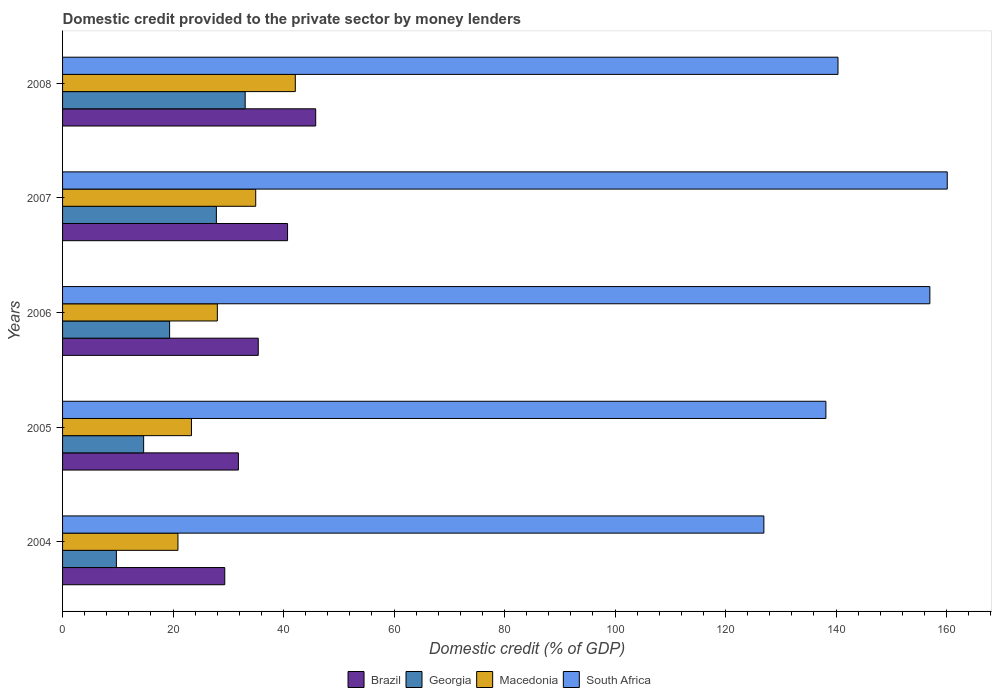How many different coloured bars are there?
Provide a succinct answer. 4. Are the number of bars on each tick of the Y-axis equal?
Your answer should be very brief. Yes. What is the domestic credit provided to the private sector by money lenders in Macedonia in 2004?
Provide a succinct answer. 20.88. Across all years, what is the maximum domestic credit provided to the private sector by money lenders in Macedonia?
Ensure brevity in your answer.  42.13. Across all years, what is the minimum domestic credit provided to the private sector by money lenders in South Africa?
Keep it short and to the point. 126.93. In which year was the domestic credit provided to the private sector by money lenders in Macedonia minimum?
Ensure brevity in your answer.  2004. What is the total domestic credit provided to the private sector by money lenders in Brazil in the graph?
Your answer should be compact. 183.14. What is the difference between the domestic credit provided to the private sector by money lenders in Georgia in 2004 and that in 2007?
Ensure brevity in your answer.  -18.1. What is the difference between the domestic credit provided to the private sector by money lenders in Georgia in 2004 and the domestic credit provided to the private sector by money lenders in Macedonia in 2007?
Your response must be concise. -25.22. What is the average domestic credit provided to the private sector by money lenders in Brazil per year?
Give a very brief answer. 36.63. In the year 2005, what is the difference between the domestic credit provided to the private sector by money lenders in Macedonia and domestic credit provided to the private sector by money lenders in South Africa?
Ensure brevity in your answer.  -114.83. What is the ratio of the domestic credit provided to the private sector by money lenders in South Africa in 2004 to that in 2006?
Provide a succinct answer. 0.81. Is the domestic credit provided to the private sector by money lenders in Georgia in 2004 less than that in 2005?
Provide a succinct answer. Yes. What is the difference between the highest and the second highest domestic credit provided to the private sector by money lenders in Macedonia?
Offer a terse response. 7.17. What is the difference between the highest and the lowest domestic credit provided to the private sector by money lenders in Brazil?
Your response must be concise. 16.46. Is the sum of the domestic credit provided to the private sector by money lenders in Georgia in 2004 and 2007 greater than the maximum domestic credit provided to the private sector by money lenders in Brazil across all years?
Ensure brevity in your answer.  No. Is it the case that in every year, the sum of the domestic credit provided to the private sector by money lenders in Macedonia and domestic credit provided to the private sector by money lenders in Brazil is greater than the sum of domestic credit provided to the private sector by money lenders in Georgia and domestic credit provided to the private sector by money lenders in South Africa?
Your answer should be compact. No. What does the 1st bar from the top in 2008 represents?
Give a very brief answer. South Africa. What does the 1st bar from the bottom in 2007 represents?
Provide a short and direct response. Brazil. Is it the case that in every year, the sum of the domestic credit provided to the private sector by money lenders in Brazil and domestic credit provided to the private sector by money lenders in South Africa is greater than the domestic credit provided to the private sector by money lenders in Georgia?
Ensure brevity in your answer.  Yes. How many bars are there?
Offer a terse response. 20. Are all the bars in the graph horizontal?
Provide a short and direct response. Yes. How many years are there in the graph?
Keep it short and to the point. 5. What is the difference between two consecutive major ticks on the X-axis?
Offer a very short reply. 20. Does the graph contain any zero values?
Ensure brevity in your answer.  No. How many legend labels are there?
Give a very brief answer. 4. How are the legend labels stacked?
Make the answer very short. Horizontal. What is the title of the graph?
Make the answer very short. Domestic credit provided to the private sector by money lenders. Does "Croatia" appear as one of the legend labels in the graph?
Offer a terse response. No. What is the label or title of the X-axis?
Offer a very short reply. Domestic credit (% of GDP). What is the Domestic credit (% of GDP) of Brazil in 2004?
Your answer should be very brief. 29.36. What is the Domestic credit (% of GDP) of Georgia in 2004?
Your response must be concise. 9.74. What is the Domestic credit (% of GDP) of Macedonia in 2004?
Ensure brevity in your answer.  20.88. What is the Domestic credit (% of GDP) in South Africa in 2004?
Keep it short and to the point. 126.93. What is the Domestic credit (% of GDP) of Brazil in 2005?
Keep it short and to the point. 31.82. What is the Domestic credit (% of GDP) in Georgia in 2005?
Give a very brief answer. 14.67. What is the Domestic credit (% of GDP) in Macedonia in 2005?
Your answer should be compact. 23.33. What is the Domestic credit (% of GDP) in South Africa in 2005?
Keep it short and to the point. 138.16. What is the Domestic credit (% of GDP) of Brazil in 2006?
Provide a short and direct response. 35.42. What is the Domestic credit (% of GDP) of Georgia in 2006?
Provide a succinct answer. 19.37. What is the Domestic credit (% of GDP) of Macedonia in 2006?
Ensure brevity in your answer.  28.01. What is the Domestic credit (% of GDP) of South Africa in 2006?
Your response must be concise. 156.98. What is the Domestic credit (% of GDP) in Brazil in 2007?
Make the answer very short. 40.72. What is the Domestic credit (% of GDP) of Georgia in 2007?
Give a very brief answer. 27.84. What is the Domestic credit (% of GDP) of Macedonia in 2007?
Your answer should be compact. 34.96. What is the Domestic credit (% of GDP) in South Africa in 2007?
Offer a very short reply. 160.12. What is the Domestic credit (% of GDP) of Brazil in 2008?
Give a very brief answer. 45.82. What is the Domestic credit (% of GDP) of Georgia in 2008?
Your answer should be compact. 33.05. What is the Domestic credit (% of GDP) of Macedonia in 2008?
Give a very brief answer. 42.13. What is the Domestic credit (% of GDP) of South Africa in 2008?
Offer a very short reply. 140.35. Across all years, what is the maximum Domestic credit (% of GDP) in Brazil?
Your answer should be very brief. 45.82. Across all years, what is the maximum Domestic credit (% of GDP) in Georgia?
Offer a terse response. 33.05. Across all years, what is the maximum Domestic credit (% of GDP) of Macedonia?
Make the answer very short. 42.13. Across all years, what is the maximum Domestic credit (% of GDP) of South Africa?
Make the answer very short. 160.12. Across all years, what is the minimum Domestic credit (% of GDP) in Brazil?
Provide a succinct answer. 29.36. Across all years, what is the minimum Domestic credit (% of GDP) of Georgia?
Provide a succinct answer. 9.74. Across all years, what is the minimum Domestic credit (% of GDP) in Macedonia?
Offer a very short reply. 20.88. Across all years, what is the minimum Domestic credit (% of GDP) of South Africa?
Provide a short and direct response. 126.93. What is the total Domestic credit (% of GDP) of Brazil in the graph?
Ensure brevity in your answer.  183.14. What is the total Domestic credit (% of GDP) in Georgia in the graph?
Your response must be concise. 104.68. What is the total Domestic credit (% of GDP) in Macedonia in the graph?
Your answer should be very brief. 149.32. What is the total Domestic credit (% of GDP) of South Africa in the graph?
Offer a terse response. 722.54. What is the difference between the Domestic credit (% of GDP) in Brazil in 2004 and that in 2005?
Keep it short and to the point. -2.46. What is the difference between the Domestic credit (% of GDP) in Georgia in 2004 and that in 2005?
Keep it short and to the point. -4.93. What is the difference between the Domestic credit (% of GDP) in Macedonia in 2004 and that in 2005?
Give a very brief answer. -2.45. What is the difference between the Domestic credit (% of GDP) of South Africa in 2004 and that in 2005?
Ensure brevity in your answer.  -11.23. What is the difference between the Domestic credit (% of GDP) of Brazil in 2004 and that in 2006?
Your answer should be very brief. -6.06. What is the difference between the Domestic credit (% of GDP) in Georgia in 2004 and that in 2006?
Make the answer very short. -9.63. What is the difference between the Domestic credit (% of GDP) in Macedonia in 2004 and that in 2006?
Offer a terse response. -7.13. What is the difference between the Domestic credit (% of GDP) of South Africa in 2004 and that in 2006?
Offer a very short reply. -30.04. What is the difference between the Domestic credit (% of GDP) of Brazil in 2004 and that in 2007?
Offer a terse response. -11.37. What is the difference between the Domestic credit (% of GDP) in Georgia in 2004 and that in 2007?
Offer a terse response. -18.1. What is the difference between the Domestic credit (% of GDP) of Macedonia in 2004 and that in 2007?
Ensure brevity in your answer.  -14.08. What is the difference between the Domestic credit (% of GDP) of South Africa in 2004 and that in 2007?
Ensure brevity in your answer.  -33.19. What is the difference between the Domestic credit (% of GDP) in Brazil in 2004 and that in 2008?
Provide a succinct answer. -16.46. What is the difference between the Domestic credit (% of GDP) of Georgia in 2004 and that in 2008?
Your response must be concise. -23.31. What is the difference between the Domestic credit (% of GDP) of Macedonia in 2004 and that in 2008?
Your response must be concise. -21.24. What is the difference between the Domestic credit (% of GDP) of South Africa in 2004 and that in 2008?
Give a very brief answer. -13.42. What is the difference between the Domestic credit (% of GDP) of Brazil in 2005 and that in 2006?
Offer a terse response. -3.6. What is the difference between the Domestic credit (% of GDP) in Georgia in 2005 and that in 2006?
Your answer should be very brief. -4.7. What is the difference between the Domestic credit (% of GDP) in Macedonia in 2005 and that in 2006?
Make the answer very short. -4.68. What is the difference between the Domestic credit (% of GDP) in South Africa in 2005 and that in 2006?
Offer a terse response. -18.82. What is the difference between the Domestic credit (% of GDP) in Brazil in 2005 and that in 2007?
Give a very brief answer. -8.9. What is the difference between the Domestic credit (% of GDP) in Georgia in 2005 and that in 2007?
Your answer should be very brief. -13.16. What is the difference between the Domestic credit (% of GDP) of Macedonia in 2005 and that in 2007?
Offer a terse response. -11.63. What is the difference between the Domestic credit (% of GDP) of South Africa in 2005 and that in 2007?
Your answer should be compact. -21.97. What is the difference between the Domestic credit (% of GDP) of Brazil in 2005 and that in 2008?
Provide a succinct answer. -13.99. What is the difference between the Domestic credit (% of GDP) of Georgia in 2005 and that in 2008?
Keep it short and to the point. -18.38. What is the difference between the Domestic credit (% of GDP) of Macedonia in 2005 and that in 2008?
Offer a terse response. -18.8. What is the difference between the Domestic credit (% of GDP) of South Africa in 2005 and that in 2008?
Offer a very short reply. -2.19. What is the difference between the Domestic credit (% of GDP) in Brazil in 2006 and that in 2007?
Make the answer very short. -5.3. What is the difference between the Domestic credit (% of GDP) of Georgia in 2006 and that in 2007?
Give a very brief answer. -8.46. What is the difference between the Domestic credit (% of GDP) of Macedonia in 2006 and that in 2007?
Ensure brevity in your answer.  -6.95. What is the difference between the Domestic credit (% of GDP) of South Africa in 2006 and that in 2007?
Provide a succinct answer. -3.15. What is the difference between the Domestic credit (% of GDP) of Brazil in 2006 and that in 2008?
Your answer should be very brief. -10.4. What is the difference between the Domestic credit (% of GDP) of Georgia in 2006 and that in 2008?
Provide a short and direct response. -13.68. What is the difference between the Domestic credit (% of GDP) of Macedonia in 2006 and that in 2008?
Make the answer very short. -14.11. What is the difference between the Domestic credit (% of GDP) of South Africa in 2006 and that in 2008?
Offer a very short reply. 16.63. What is the difference between the Domestic credit (% of GDP) of Brazil in 2007 and that in 2008?
Give a very brief answer. -5.09. What is the difference between the Domestic credit (% of GDP) in Georgia in 2007 and that in 2008?
Keep it short and to the point. -5.21. What is the difference between the Domestic credit (% of GDP) of Macedonia in 2007 and that in 2008?
Your answer should be compact. -7.17. What is the difference between the Domestic credit (% of GDP) in South Africa in 2007 and that in 2008?
Your answer should be very brief. 19.77. What is the difference between the Domestic credit (% of GDP) of Brazil in 2004 and the Domestic credit (% of GDP) of Georgia in 2005?
Provide a succinct answer. 14.68. What is the difference between the Domestic credit (% of GDP) in Brazil in 2004 and the Domestic credit (% of GDP) in Macedonia in 2005?
Ensure brevity in your answer.  6.03. What is the difference between the Domestic credit (% of GDP) of Brazil in 2004 and the Domestic credit (% of GDP) of South Africa in 2005?
Ensure brevity in your answer.  -108.8. What is the difference between the Domestic credit (% of GDP) in Georgia in 2004 and the Domestic credit (% of GDP) in Macedonia in 2005?
Offer a very short reply. -13.59. What is the difference between the Domestic credit (% of GDP) in Georgia in 2004 and the Domestic credit (% of GDP) in South Africa in 2005?
Your response must be concise. -128.42. What is the difference between the Domestic credit (% of GDP) in Macedonia in 2004 and the Domestic credit (% of GDP) in South Africa in 2005?
Your answer should be very brief. -117.28. What is the difference between the Domestic credit (% of GDP) of Brazil in 2004 and the Domestic credit (% of GDP) of Georgia in 2006?
Your answer should be very brief. 9.98. What is the difference between the Domestic credit (% of GDP) in Brazil in 2004 and the Domestic credit (% of GDP) in Macedonia in 2006?
Provide a succinct answer. 1.34. What is the difference between the Domestic credit (% of GDP) of Brazil in 2004 and the Domestic credit (% of GDP) of South Africa in 2006?
Make the answer very short. -127.62. What is the difference between the Domestic credit (% of GDP) in Georgia in 2004 and the Domestic credit (% of GDP) in Macedonia in 2006?
Make the answer very short. -18.27. What is the difference between the Domestic credit (% of GDP) in Georgia in 2004 and the Domestic credit (% of GDP) in South Africa in 2006?
Your response must be concise. -147.23. What is the difference between the Domestic credit (% of GDP) of Macedonia in 2004 and the Domestic credit (% of GDP) of South Africa in 2006?
Your answer should be very brief. -136.09. What is the difference between the Domestic credit (% of GDP) of Brazil in 2004 and the Domestic credit (% of GDP) of Georgia in 2007?
Provide a succinct answer. 1.52. What is the difference between the Domestic credit (% of GDP) in Brazil in 2004 and the Domestic credit (% of GDP) in Macedonia in 2007?
Your answer should be compact. -5.6. What is the difference between the Domestic credit (% of GDP) of Brazil in 2004 and the Domestic credit (% of GDP) of South Africa in 2007?
Offer a very short reply. -130.77. What is the difference between the Domestic credit (% of GDP) in Georgia in 2004 and the Domestic credit (% of GDP) in Macedonia in 2007?
Keep it short and to the point. -25.22. What is the difference between the Domestic credit (% of GDP) in Georgia in 2004 and the Domestic credit (% of GDP) in South Africa in 2007?
Provide a short and direct response. -150.38. What is the difference between the Domestic credit (% of GDP) of Macedonia in 2004 and the Domestic credit (% of GDP) of South Africa in 2007?
Offer a terse response. -139.24. What is the difference between the Domestic credit (% of GDP) in Brazil in 2004 and the Domestic credit (% of GDP) in Georgia in 2008?
Keep it short and to the point. -3.69. What is the difference between the Domestic credit (% of GDP) of Brazil in 2004 and the Domestic credit (% of GDP) of Macedonia in 2008?
Provide a short and direct response. -12.77. What is the difference between the Domestic credit (% of GDP) of Brazil in 2004 and the Domestic credit (% of GDP) of South Africa in 2008?
Your answer should be very brief. -110.99. What is the difference between the Domestic credit (% of GDP) in Georgia in 2004 and the Domestic credit (% of GDP) in Macedonia in 2008?
Offer a very short reply. -32.39. What is the difference between the Domestic credit (% of GDP) of Georgia in 2004 and the Domestic credit (% of GDP) of South Africa in 2008?
Keep it short and to the point. -130.61. What is the difference between the Domestic credit (% of GDP) of Macedonia in 2004 and the Domestic credit (% of GDP) of South Africa in 2008?
Make the answer very short. -119.47. What is the difference between the Domestic credit (% of GDP) in Brazil in 2005 and the Domestic credit (% of GDP) in Georgia in 2006?
Offer a very short reply. 12.45. What is the difference between the Domestic credit (% of GDP) of Brazil in 2005 and the Domestic credit (% of GDP) of Macedonia in 2006?
Give a very brief answer. 3.81. What is the difference between the Domestic credit (% of GDP) of Brazil in 2005 and the Domestic credit (% of GDP) of South Africa in 2006?
Offer a terse response. -125.15. What is the difference between the Domestic credit (% of GDP) in Georgia in 2005 and the Domestic credit (% of GDP) in Macedonia in 2006?
Your response must be concise. -13.34. What is the difference between the Domestic credit (% of GDP) in Georgia in 2005 and the Domestic credit (% of GDP) in South Africa in 2006?
Offer a terse response. -142.3. What is the difference between the Domestic credit (% of GDP) of Macedonia in 2005 and the Domestic credit (% of GDP) of South Africa in 2006?
Provide a succinct answer. -133.64. What is the difference between the Domestic credit (% of GDP) in Brazil in 2005 and the Domestic credit (% of GDP) in Georgia in 2007?
Provide a short and direct response. 3.99. What is the difference between the Domestic credit (% of GDP) of Brazil in 2005 and the Domestic credit (% of GDP) of Macedonia in 2007?
Give a very brief answer. -3.14. What is the difference between the Domestic credit (% of GDP) of Brazil in 2005 and the Domestic credit (% of GDP) of South Africa in 2007?
Your response must be concise. -128.3. What is the difference between the Domestic credit (% of GDP) in Georgia in 2005 and the Domestic credit (% of GDP) in Macedonia in 2007?
Offer a very short reply. -20.29. What is the difference between the Domestic credit (% of GDP) of Georgia in 2005 and the Domestic credit (% of GDP) of South Africa in 2007?
Your answer should be compact. -145.45. What is the difference between the Domestic credit (% of GDP) in Macedonia in 2005 and the Domestic credit (% of GDP) in South Africa in 2007?
Make the answer very short. -136.79. What is the difference between the Domestic credit (% of GDP) of Brazil in 2005 and the Domestic credit (% of GDP) of Georgia in 2008?
Give a very brief answer. -1.23. What is the difference between the Domestic credit (% of GDP) of Brazil in 2005 and the Domestic credit (% of GDP) of Macedonia in 2008?
Provide a short and direct response. -10.3. What is the difference between the Domestic credit (% of GDP) in Brazil in 2005 and the Domestic credit (% of GDP) in South Africa in 2008?
Your response must be concise. -108.53. What is the difference between the Domestic credit (% of GDP) in Georgia in 2005 and the Domestic credit (% of GDP) in Macedonia in 2008?
Provide a short and direct response. -27.45. What is the difference between the Domestic credit (% of GDP) in Georgia in 2005 and the Domestic credit (% of GDP) in South Africa in 2008?
Your response must be concise. -125.68. What is the difference between the Domestic credit (% of GDP) of Macedonia in 2005 and the Domestic credit (% of GDP) of South Africa in 2008?
Provide a short and direct response. -117.02. What is the difference between the Domestic credit (% of GDP) in Brazil in 2006 and the Domestic credit (% of GDP) in Georgia in 2007?
Provide a succinct answer. 7.58. What is the difference between the Domestic credit (% of GDP) in Brazil in 2006 and the Domestic credit (% of GDP) in Macedonia in 2007?
Your answer should be very brief. 0.46. What is the difference between the Domestic credit (% of GDP) in Brazil in 2006 and the Domestic credit (% of GDP) in South Africa in 2007?
Offer a very short reply. -124.7. What is the difference between the Domestic credit (% of GDP) of Georgia in 2006 and the Domestic credit (% of GDP) of Macedonia in 2007?
Give a very brief answer. -15.59. What is the difference between the Domestic credit (% of GDP) in Georgia in 2006 and the Domestic credit (% of GDP) in South Africa in 2007?
Offer a terse response. -140.75. What is the difference between the Domestic credit (% of GDP) in Macedonia in 2006 and the Domestic credit (% of GDP) in South Africa in 2007?
Ensure brevity in your answer.  -132.11. What is the difference between the Domestic credit (% of GDP) in Brazil in 2006 and the Domestic credit (% of GDP) in Georgia in 2008?
Give a very brief answer. 2.37. What is the difference between the Domestic credit (% of GDP) of Brazil in 2006 and the Domestic credit (% of GDP) of Macedonia in 2008?
Offer a very short reply. -6.71. What is the difference between the Domestic credit (% of GDP) in Brazil in 2006 and the Domestic credit (% of GDP) in South Africa in 2008?
Ensure brevity in your answer.  -104.93. What is the difference between the Domestic credit (% of GDP) of Georgia in 2006 and the Domestic credit (% of GDP) of Macedonia in 2008?
Offer a very short reply. -22.75. What is the difference between the Domestic credit (% of GDP) of Georgia in 2006 and the Domestic credit (% of GDP) of South Africa in 2008?
Your answer should be compact. -120.98. What is the difference between the Domestic credit (% of GDP) in Macedonia in 2006 and the Domestic credit (% of GDP) in South Africa in 2008?
Ensure brevity in your answer.  -112.34. What is the difference between the Domestic credit (% of GDP) of Brazil in 2007 and the Domestic credit (% of GDP) of Georgia in 2008?
Provide a succinct answer. 7.67. What is the difference between the Domestic credit (% of GDP) in Brazil in 2007 and the Domestic credit (% of GDP) in Macedonia in 2008?
Give a very brief answer. -1.4. What is the difference between the Domestic credit (% of GDP) of Brazil in 2007 and the Domestic credit (% of GDP) of South Africa in 2008?
Offer a very short reply. -99.63. What is the difference between the Domestic credit (% of GDP) of Georgia in 2007 and the Domestic credit (% of GDP) of Macedonia in 2008?
Offer a terse response. -14.29. What is the difference between the Domestic credit (% of GDP) in Georgia in 2007 and the Domestic credit (% of GDP) in South Africa in 2008?
Make the answer very short. -112.51. What is the difference between the Domestic credit (% of GDP) of Macedonia in 2007 and the Domestic credit (% of GDP) of South Africa in 2008?
Your answer should be compact. -105.39. What is the average Domestic credit (% of GDP) in Brazil per year?
Provide a succinct answer. 36.63. What is the average Domestic credit (% of GDP) in Georgia per year?
Your answer should be very brief. 20.94. What is the average Domestic credit (% of GDP) of Macedonia per year?
Keep it short and to the point. 29.86. What is the average Domestic credit (% of GDP) in South Africa per year?
Ensure brevity in your answer.  144.51. In the year 2004, what is the difference between the Domestic credit (% of GDP) of Brazil and Domestic credit (% of GDP) of Georgia?
Ensure brevity in your answer.  19.62. In the year 2004, what is the difference between the Domestic credit (% of GDP) of Brazil and Domestic credit (% of GDP) of Macedonia?
Provide a succinct answer. 8.47. In the year 2004, what is the difference between the Domestic credit (% of GDP) in Brazil and Domestic credit (% of GDP) in South Africa?
Offer a terse response. -97.57. In the year 2004, what is the difference between the Domestic credit (% of GDP) in Georgia and Domestic credit (% of GDP) in Macedonia?
Your answer should be compact. -11.14. In the year 2004, what is the difference between the Domestic credit (% of GDP) of Georgia and Domestic credit (% of GDP) of South Africa?
Provide a short and direct response. -117.19. In the year 2004, what is the difference between the Domestic credit (% of GDP) in Macedonia and Domestic credit (% of GDP) in South Africa?
Your answer should be compact. -106.05. In the year 2005, what is the difference between the Domestic credit (% of GDP) in Brazil and Domestic credit (% of GDP) in Georgia?
Offer a very short reply. 17.15. In the year 2005, what is the difference between the Domestic credit (% of GDP) in Brazil and Domestic credit (% of GDP) in Macedonia?
Your response must be concise. 8.49. In the year 2005, what is the difference between the Domestic credit (% of GDP) of Brazil and Domestic credit (% of GDP) of South Africa?
Make the answer very short. -106.34. In the year 2005, what is the difference between the Domestic credit (% of GDP) of Georgia and Domestic credit (% of GDP) of Macedonia?
Make the answer very short. -8.66. In the year 2005, what is the difference between the Domestic credit (% of GDP) in Georgia and Domestic credit (% of GDP) in South Africa?
Offer a terse response. -123.49. In the year 2005, what is the difference between the Domestic credit (% of GDP) in Macedonia and Domestic credit (% of GDP) in South Africa?
Offer a terse response. -114.83. In the year 2006, what is the difference between the Domestic credit (% of GDP) of Brazil and Domestic credit (% of GDP) of Georgia?
Provide a succinct answer. 16.05. In the year 2006, what is the difference between the Domestic credit (% of GDP) of Brazil and Domestic credit (% of GDP) of Macedonia?
Make the answer very short. 7.41. In the year 2006, what is the difference between the Domestic credit (% of GDP) of Brazil and Domestic credit (% of GDP) of South Africa?
Provide a succinct answer. -121.56. In the year 2006, what is the difference between the Domestic credit (% of GDP) in Georgia and Domestic credit (% of GDP) in Macedonia?
Offer a very short reply. -8.64. In the year 2006, what is the difference between the Domestic credit (% of GDP) of Georgia and Domestic credit (% of GDP) of South Africa?
Keep it short and to the point. -137.6. In the year 2006, what is the difference between the Domestic credit (% of GDP) of Macedonia and Domestic credit (% of GDP) of South Africa?
Give a very brief answer. -128.96. In the year 2007, what is the difference between the Domestic credit (% of GDP) in Brazil and Domestic credit (% of GDP) in Georgia?
Give a very brief answer. 12.89. In the year 2007, what is the difference between the Domestic credit (% of GDP) of Brazil and Domestic credit (% of GDP) of Macedonia?
Your response must be concise. 5.76. In the year 2007, what is the difference between the Domestic credit (% of GDP) in Brazil and Domestic credit (% of GDP) in South Africa?
Provide a succinct answer. -119.4. In the year 2007, what is the difference between the Domestic credit (% of GDP) of Georgia and Domestic credit (% of GDP) of Macedonia?
Your answer should be very brief. -7.12. In the year 2007, what is the difference between the Domestic credit (% of GDP) in Georgia and Domestic credit (% of GDP) in South Africa?
Ensure brevity in your answer.  -132.29. In the year 2007, what is the difference between the Domestic credit (% of GDP) of Macedonia and Domestic credit (% of GDP) of South Africa?
Make the answer very short. -125.16. In the year 2008, what is the difference between the Domestic credit (% of GDP) in Brazil and Domestic credit (% of GDP) in Georgia?
Provide a short and direct response. 12.77. In the year 2008, what is the difference between the Domestic credit (% of GDP) in Brazil and Domestic credit (% of GDP) in Macedonia?
Offer a very short reply. 3.69. In the year 2008, what is the difference between the Domestic credit (% of GDP) of Brazil and Domestic credit (% of GDP) of South Africa?
Your answer should be compact. -94.53. In the year 2008, what is the difference between the Domestic credit (% of GDP) of Georgia and Domestic credit (% of GDP) of Macedonia?
Your answer should be very brief. -9.08. In the year 2008, what is the difference between the Domestic credit (% of GDP) of Georgia and Domestic credit (% of GDP) of South Africa?
Your answer should be very brief. -107.3. In the year 2008, what is the difference between the Domestic credit (% of GDP) in Macedonia and Domestic credit (% of GDP) in South Africa?
Provide a short and direct response. -98.22. What is the ratio of the Domestic credit (% of GDP) of Brazil in 2004 to that in 2005?
Ensure brevity in your answer.  0.92. What is the ratio of the Domestic credit (% of GDP) of Georgia in 2004 to that in 2005?
Provide a succinct answer. 0.66. What is the ratio of the Domestic credit (% of GDP) in Macedonia in 2004 to that in 2005?
Provide a short and direct response. 0.9. What is the ratio of the Domestic credit (% of GDP) of South Africa in 2004 to that in 2005?
Your response must be concise. 0.92. What is the ratio of the Domestic credit (% of GDP) in Brazil in 2004 to that in 2006?
Make the answer very short. 0.83. What is the ratio of the Domestic credit (% of GDP) of Georgia in 2004 to that in 2006?
Offer a very short reply. 0.5. What is the ratio of the Domestic credit (% of GDP) in Macedonia in 2004 to that in 2006?
Give a very brief answer. 0.75. What is the ratio of the Domestic credit (% of GDP) in South Africa in 2004 to that in 2006?
Make the answer very short. 0.81. What is the ratio of the Domestic credit (% of GDP) in Brazil in 2004 to that in 2007?
Provide a short and direct response. 0.72. What is the ratio of the Domestic credit (% of GDP) of Georgia in 2004 to that in 2007?
Offer a terse response. 0.35. What is the ratio of the Domestic credit (% of GDP) of Macedonia in 2004 to that in 2007?
Keep it short and to the point. 0.6. What is the ratio of the Domestic credit (% of GDP) of South Africa in 2004 to that in 2007?
Your response must be concise. 0.79. What is the ratio of the Domestic credit (% of GDP) of Brazil in 2004 to that in 2008?
Your answer should be very brief. 0.64. What is the ratio of the Domestic credit (% of GDP) of Georgia in 2004 to that in 2008?
Your answer should be compact. 0.29. What is the ratio of the Domestic credit (% of GDP) in Macedonia in 2004 to that in 2008?
Your response must be concise. 0.5. What is the ratio of the Domestic credit (% of GDP) in South Africa in 2004 to that in 2008?
Give a very brief answer. 0.9. What is the ratio of the Domestic credit (% of GDP) in Brazil in 2005 to that in 2006?
Ensure brevity in your answer.  0.9. What is the ratio of the Domestic credit (% of GDP) in Georgia in 2005 to that in 2006?
Make the answer very short. 0.76. What is the ratio of the Domestic credit (% of GDP) in Macedonia in 2005 to that in 2006?
Your answer should be compact. 0.83. What is the ratio of the Domestic credit (% of GDP) in South Africa in 2005 to that in 2006?
Ensure brevity in your answer.  0.88. What is the ratio of the Domestic credit (% of GDP) in Brazil in 2005 to that in 2007?
Offer a terse response. 0.78. What is the ratio of the Domestic credit (% of GDP) in Georgia in 2005 to that in 2007?
Provide a short and direct response. 0.53. What is the ratio of the Domestic credit (% of GDP) of Macedonia in 2005 to that in 2007?
Your answer should be very brief. 0.67. What is the ratio of the Domestic credit (% of GDP) of South Africa in 2005 to that in 2007?
Your answer should be compact. 0.86. What is the ratio of the Domestic credit (% of GDP) in Brazil in 2005 to that in 2008?
Make the answer very short. 0.69. What is the ratio of the Domestic credit (% of GDP) of Georgia in 2005 to that in 2008?
Make the answer very short. 0.44. What is the ratio of the Domestic credit (% of GDP) in Macedonia in 2005 to that in 2008?
Ensure brevity in your answer.  0.55. What is the ratio of the Domestic credit (% of GDP) of South Africa in 2005 to that in 2008?
Offer a terse response. 0.98. What is the ratio of the Domestic credit (% of GDP) in Brazil in 2006 to that in 2007?
Offer a very short reply. 0.87. What is the ratio of the Domestic credit (% of GDP) in Georgia in 2006 to that in 2007?
Ensure brevity in your answer.  0.7. What is the ratio of the Domestic credit (% of GDP) of Macedonia in 2006 to that in 2007?
Offer a terse response. 0.8. What is the ratio of the Domestic credit (% of GDP) of South Africa in 2006 to that in 2007?
Ensure brevity in your answer.  0.98. What is the ratio of the Domestic credit (% of GDP) in Brazil in 2006 to that in 2008?
Ensure brevity in your answer.  0.77. What is the ratio of the Domestic credit (% of GDP) of Georgia in 2006 to that in 2008?
Give a very brief answer. 0.59. What is the ratio of the Domestic credit (% of GDP) of Macedonia in 2006 to that in 2008?
Your response must be concise. 0.67. What is the ratio of the Domestic credit (% of GDP) of South Africa in 2006 to that in 2008?
Offer a terse response. 1.12. What is the ratio of the Domestic credit (% of GDP) of Georgia in 2007 to that in 2008?
Ensure brevity in your answer.  0.84. What is the ratio of the Domestic credit (% of GDP) in Macedonia in 2007 to that in 2008?
Give a very brief answer. 0.83. What is the ratio of the Domestic credit (% of GDP) of South Africa in 2007 to that in 2008?
Provide a succinct answer. 1.14. What is the difference between the highest and the second highest Domestic credit (% of GDP) of Brazil?
Offer a very short reply. 5.09. What is the difference between the highest and the second highest Domestic credit (% of GDP) of Georgia?
Provide a short and direct response. 5.21. What is the difference between the highest and the second highest Domestic credit (% of GDP) of Macedonia?
Provide a succinct answer. 7.17. What is the difference between the highest and the second highest Domestic credit (% of GDP) of South Africa?
Offer a terse response. 3.15. What is the difference between the highest and the lowest Domestic credit (% of GDP) in Brazil?
Make the answer very short. 16.46. What is the difference between the highest and the lowest Domestic credit (% of GDP) in Georgia?
Offer a terse response. 23.31. What is the difference between the highest and the lowest Domestic credit (% of GDP) in Macedonia?
Make the answer very short. 21.24. What is the difference between the highest and the lowest Domestic credit (% of GDP) of South Africa?
Provide a short and direct response. 33.19. 